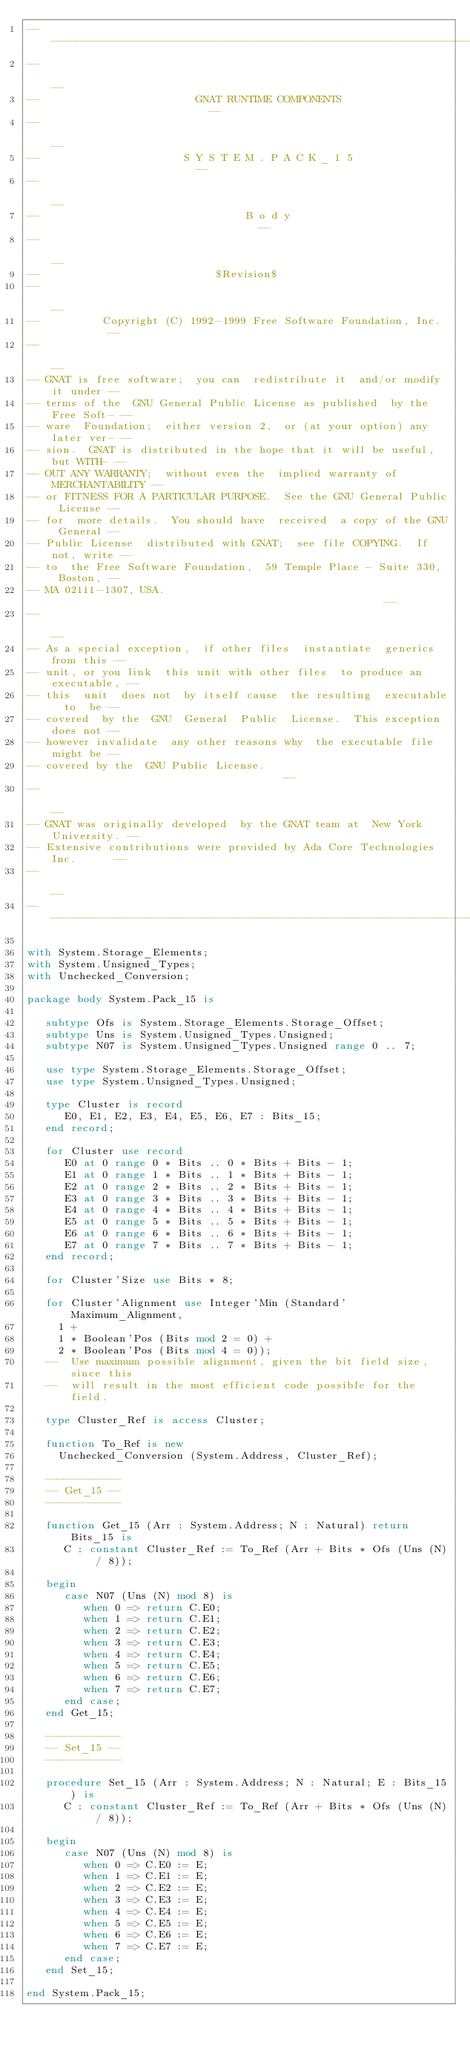Convert code to text. <code><loc_0><loc_0><loc_500><loc_500><_Ada_>------------------------------------------------------------------------------
--                                                                          --
--                         GNAT RUNTIME COMPONENTS                          --
--                                                                          --
--                       S Y S T E M . P A C K _ 1 5                        --
--                                                                          --
--                                 B o d y                                  --
--                                                                          --
--                            $Revision$
--                                                                          --
--          Copyright (C) 1992-1999 Free Software Foundation, Inc.          --
--                                                                          --
-- GNAT is free software;  you can  redistribute it  and/or modify it under --
-- terms of the  GNU General Public License as published  by the Free Soft- --
-- ware  Foundation;  either version 2,  or (at your option) any later ver- --
-- sion.  GNAT is distributed in the hope that it will be useful, but WITH- --
-- OUT ANY WARRANTY;  without even the  implied warranty of MERCHANTABILITY --
-- or FITNESS FOR A PARTICULAR PURPOSE.  See the GNU General Public License --
-- for  more details.  You should have  received  a copy of the GNU General --
-- Public License  distributed with GNAT;  see file COPYING.  If not, write --
-- to  the Free Software Foundation,  59 Temple Place - Suite 330,  Boston, --
-- MA 02111-1307, USA.                                                      --
--                                                                          --
-- As a special exception,  if other files  instantiate  generics from this --
-- unit, or you link  this unit with other files  to produce an executable, --
-- this  unit  does not  by itself cause  the resulting  executable  to  be --
-- covered  by the  GNU  General  Public  License.  This exception does not --
-- however invalidate  any other reasons why  the executable file  might be --
-- covered by the  GNU Public License.                                      --
--                                                                          --
-- GNAT was originally developed  by the GNAT team at  New York University. --
-- Extensive contributions were provided by Ada Core Technologies Inc.      --
--                                                                          --
------------------------------------------------------------------------------

with System.Storage_Elements;
with System.Unsigned_Types;
with Unchecked_Conversion;

package body System.Pack_15 is

   subtype Ofs is System.Storage_Elements.Storage_Offset;
   subtype Uns is System.Unsigned_Types.Unsigned;
   subtype N07 is System.Unsigned_Types.Unsigned range 0 .. 7;

   use type System.Storage_Elements.Storage_Offset;
   use type System.Unsigned_Types.Unsigned;

   type Cluster is record
      E0, E1, E2, E3, E4, E5, E6, E7 : Bits_15;
   end record;

   for Cluster use record
      E0 at 0 range 0 * Bits .. 0 * Bits + Bits - 1;
      E1 at 0 range 1 * Bits .. 1 * Bits + Bits - 1;
      E2 at 0 range 2 * Bits .. 2 * Bits + Bits - 1;
      E3 at 0 range 3 * Bits .. 3 * Bits + Bits - 1;
      E4 at 0 range 4 * Bits .. 4 * Bits + Bits - 1;
      E5 at 0 range 5 * Bits .. 5 * Bits + Bits - 1;
      E6 at 0 range 6 * Bits .. 6 * Bits + Bits - 1;
      E7 at 0 range 7 * Bits .. 7 * Bits + Bits - 1;
   end record;

   for Cluster'Size use Bits * 8;

   for Cluster'Alignment use Integer'Min (Standard'Maximum_Alignment,
     1 +
     1 * Boolean'Pos (Bits mod 2 = 0) +
     2 * Boolean'Pos (Bits mod 4 = 0));
   --  Use maximum possible alignment, given the bit field size, since this
   --  will result in the most efficient code possible for the field.

   type Cluster_Ref is access Cluster;

   function To_Ref is new
     Unchecked_Conversion (System.Address, Cluster_Ref);

   ------------
   -- Get_15 --
   ------------

   function Get_15 (Arr : System.Address; N : Natural) return Bits_15 is
      C : constant Cluster_Ref := To_Ref (Arr + Bits * Ofs (Uns (N) / 8));

   begin
      case N07 (Uns (N) mod 8) is
         when 0 => return C.E0;
         when 1 => return C.E1;
         when 2 => return C.E2;
         when 3 => return C.E3;
         when 4 => return C.E4;
         when 5 => return C.E5;
         when 6 => return C.E6;
         when 7 => return C.E7;
      end case;
   end Get_15;

   ------------
   -- Set_15 --
   ------------

   procedure Set_15 (Arr : System.Address; N : Natural; E : Bits_15) is
      C : constant Cluster_Ref := To_Ref (Arr + Bits * Ofs (Uns (N) / 8));

   begin
      case N07 (Uns (N) mod 8) is
         when 0 => C.E0 := E;
         when 1 => C.E1 := E;
         when 2 => C.E2 := E;
         when 3 => C.E3 := E;
         when 4 => C.E4 := E;
         when 5 => C.E5 := E;
         when 6 => C.E6 := E;
         when 7 => C.E7 := E;
      end case;
   end Set_15;

end System.Pack_15;
</code> 